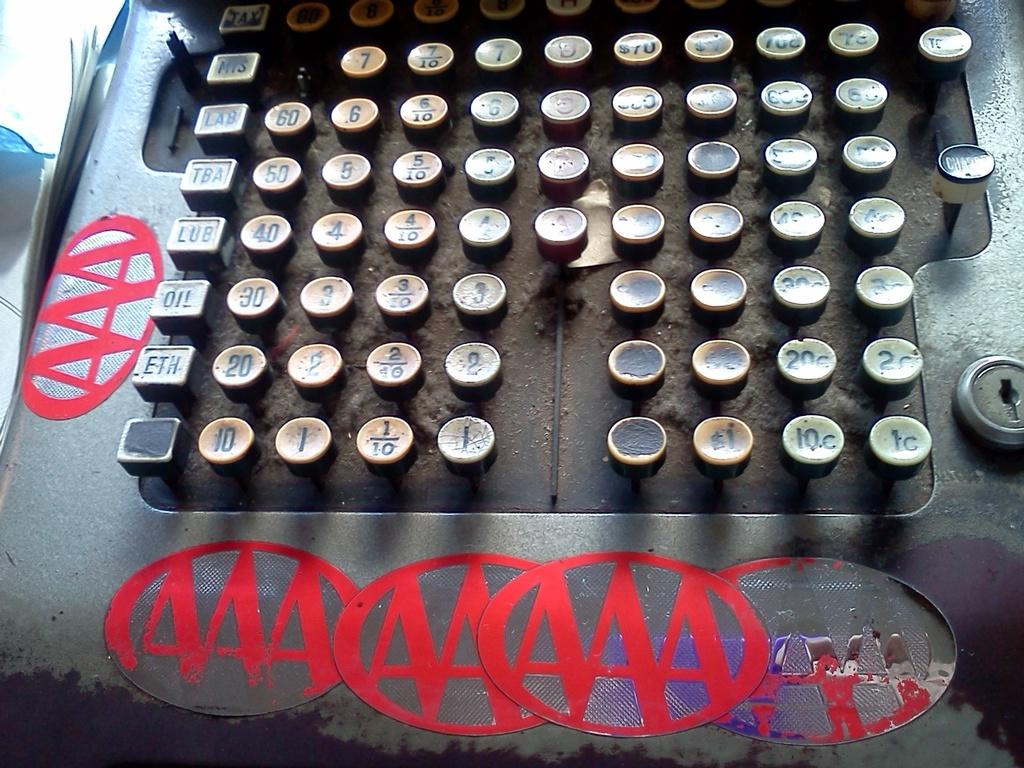<image>
Present a compact description of the photo's key features. The keys of an old cash register with Triple A stickers stuck all around them 